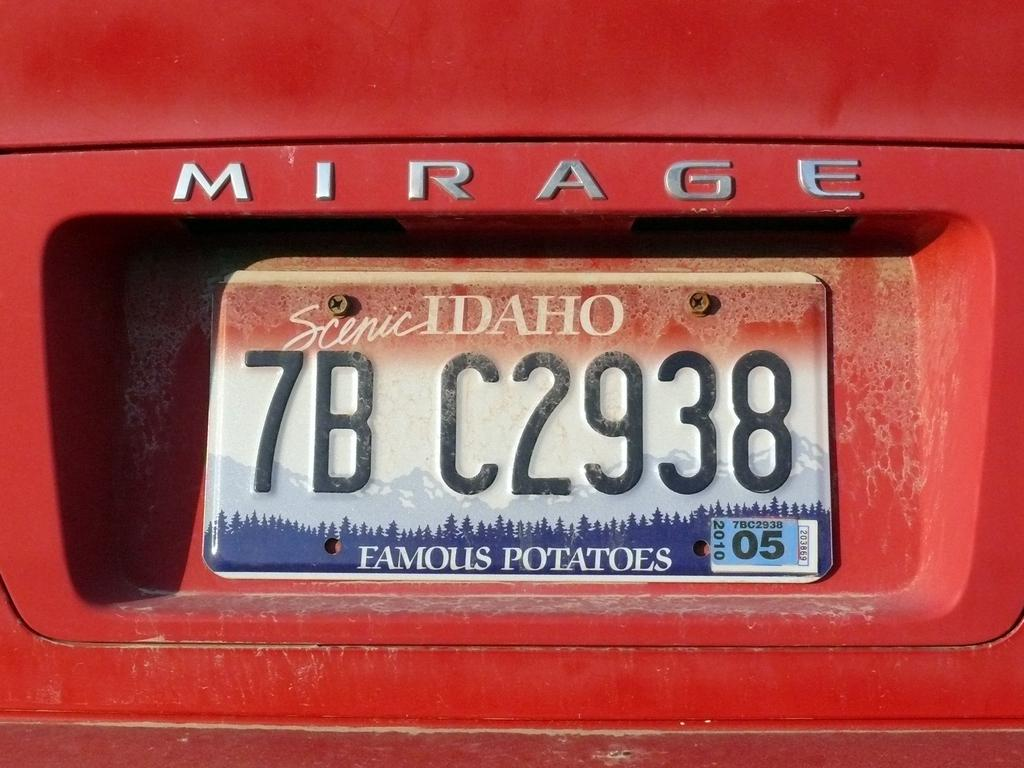<image>
Write a terse but informative summary of the picture. Red car with a license plate that says IDAHO on it. 